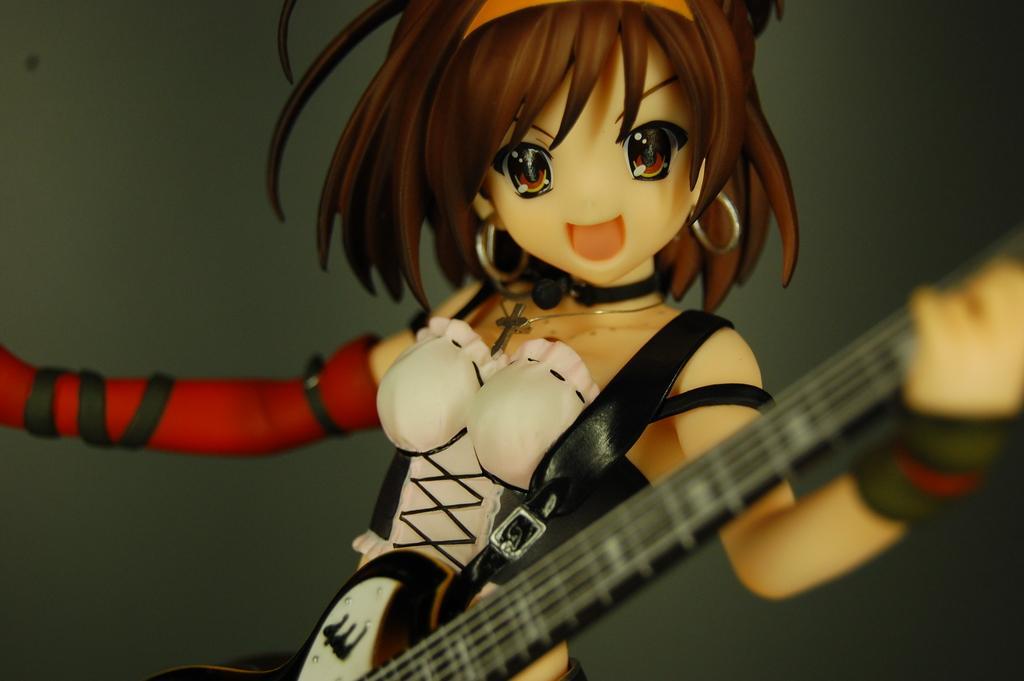Describe this image in one or two sentences. In this image there is a cartoon character. 